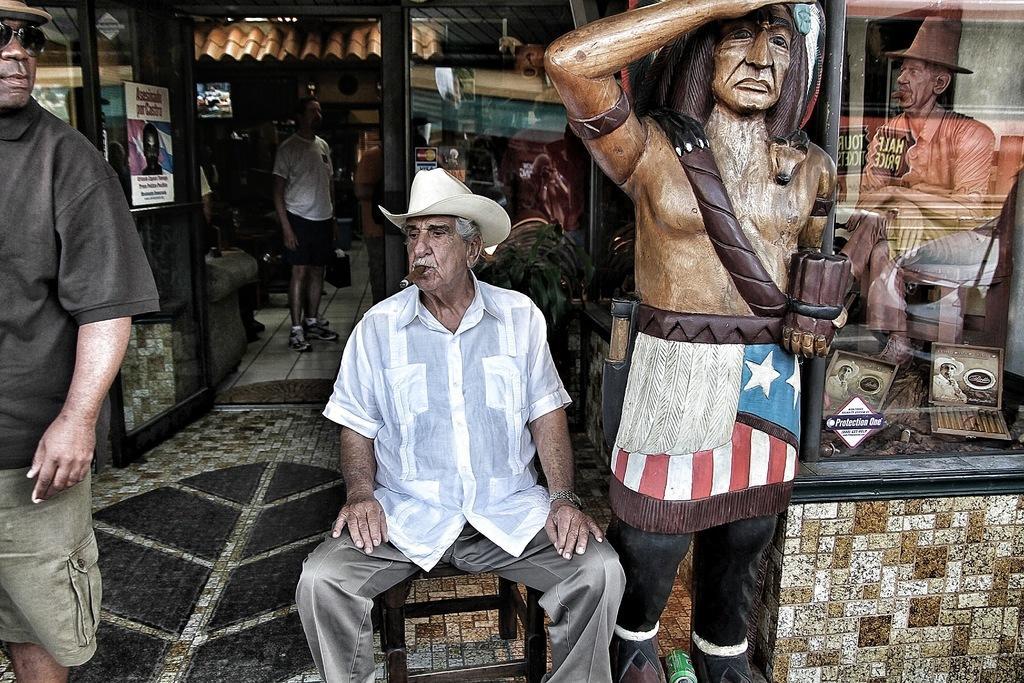Could you give a brief overview of what you see in this image? In this picture there is a man sitting on the stool, holding a cigar in his mouth. He is wearing a hat on his head. On the left side there is another man standing. We can observe a statue on the right side. In the background there is a man standing. We can observe a glass door to which a paper was stuck. 